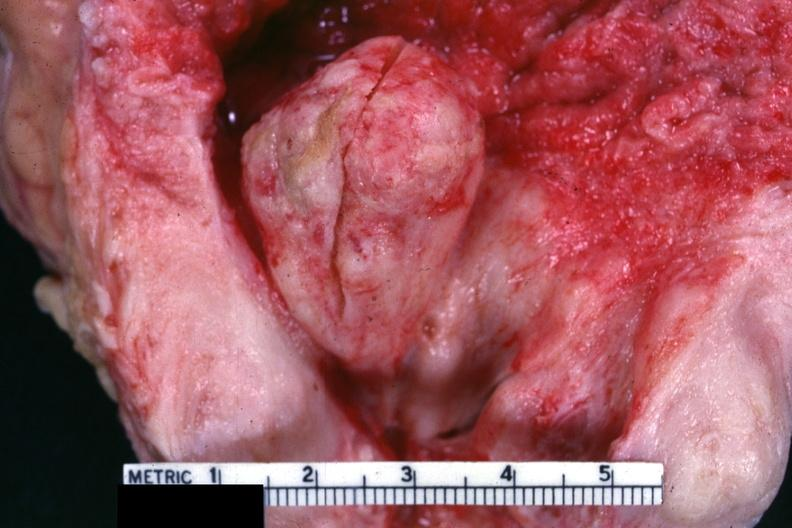what is present?
Answer the question using a single word or phrase. Hyperplasia 